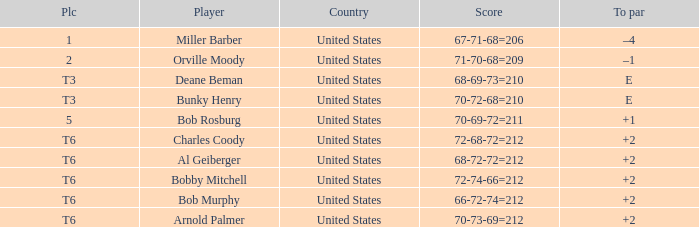What is the place of the 68-69-73=210? T3. 